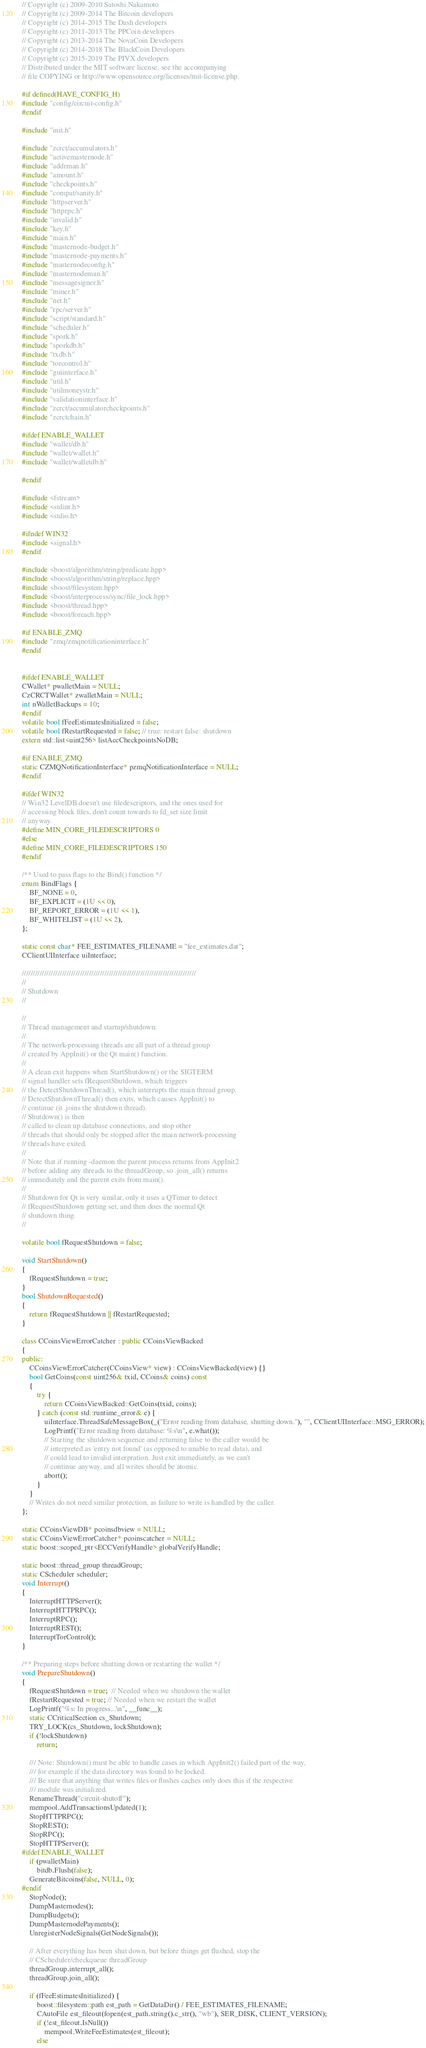Convert code to text. <code><loc_0><loc_0><loc_500><loc_500><_C++_>// Copyright (c) 2009-2010 Satoshi Nakamoto
// Copyright (c) 2009-2014 The Bitcoin developers
// Copyright (c) 2014-2015 The Dash developers
// Copyright (c) 2011-2013 The PPCoin developers
// Copyright (c) 2013-2014 The NovaCoin Developers
// Copyright (c) 2014-2018 The BlackCoin Developers
// Copyright (c) 2015-2019 The PIVX developers
// Distributed under the MIT software license, see the accompanying
// file COPYING or http://www.opensource.org/licenses/mit-license.php.

#if defined(HAVE_CONFIG_H)
#include "config/circuit-config.h"
#endif

#include "init.h"

#include "zcrct/accumulators.h"
#include "activemasternode.h"
#include "addrman.h"
#include "amount.h"
#include "checkpoints.h"
#include "compat/sanity.h"
#include "httpserver.h"
#include "httprpc.h"
#include "invalid.h"
#include "key.h"
#include "main.h"
#include "masternode-budget.h"
#include "masternode-payments.h"
#include "masternodeconfig.h"
#include "masternodeman.h"
#include "messagesigner.h"
#include "miner.h"
#include "net.h"
#include "rpc/server.h"
#include "script/standard.h"
#include "scheduler.h"
#include "spork.h"
#include "sporkdb.h"
#include "txdb.h"
#include "torcontrol.h"
#include "guiinterface.h"
#include "util.h"
#include "utilmoneystr.h"
#include "validationinterface.h"
#include "zcrct/accumulatorcheckpoints.h"
#include "zcrctchain.h"

#ifdef ENABLE_WALLET
#include "wallet/db.h"
#include "wallet/wallet.h"
#include "wallet/walletdb.h"

#endif

#include <fstream>
#include <stdint.h>
#include <stdio.h>

#ifndef WIN32
#include <signal.h>
#endif

#include <boost/algorithm/string/predicate.hpp>
#include <boost/algorithm/string/replace.hpp>
#include <boost/filesystem.hpp>
#include <boost/interprocess/sync/file_lock.hpp>
#include <boost/thread.hpp>
#include <boost/foreach.hpp>

#if ENABLE_ZMQ
#include "zmq/zmqnotificationinterface.h"
#endif


#ifdef ENABLE_WALLET
CWallet* pwalletMain = NULL;
CzCRCTWallet* zwalletMain = NULL;
int nWalletBackups = 10;
#endif
volatile bool fFeeEstimatesInitialized = false;
volatile bool fRestartRequested = false; // true: restart false: shutdown
extern std::list<uint256> listAccCheckpointsNoDB;

#if ENABLE_ZMQ
static CZMQNotificationInterface* pzmqNotificationInterface = NULL;
#endif

#ifdef WIN32
// Win32 LevelDB doesn't use filedescriptors, and the ones used for
// accessing block files, don't count towards to fd_set size limit
// anyway.
#define MIN_CORE_FILEDESCRIPTORS 0
#else
#define MIN_CORE_FILEDESCRIPTORS 150
#endif

/** Used to pass flags to the Bind() function */
enum BindFlags {
    BF_NONE = 0,
    BF_EXPLICIT = (1U << 0),
    BF_REPORT_ERROR = (1U << 1),
    BF_WHITELIST = (1U << 2),
};

static const char* FEE_ESTIMATES_FILENAME = "fee_estimates.dat";
CClientUIInterface uiInterface;

//////////////////////////////////////////////////////////////////////////////
//
// Shutdown
//

//
// Thread management and startup/shutdown:
//
// The network-processing threads are all part of a thread group
// created by AppInit() or the Qt main() function.
//
// A clean exit happens when StartShutdown() or the SIGTERM
// signal handler sets fRequestShutdown, which triggers
// the DetectShutdownThread(), which interrupts the main thread group.
// DetectShutdownThread() then exits, which causes AppInit() to
// continue (it .joins the shutdown thread).
// Shutdown() is then
// called to clean up database connections, and stop other
// threads that should only be stopped after the main network-processing
// threads have exited.
//
// Note that if running -daemon the parent process returns from AppInit2
// before adding any threads to the threadGroup, so .join_all() returns
// immediately and the parent exits from main().
//
// Shutdown for Qt is very similar, only it uses a QTimer to detect
// fRequestShutdown getting set, and then does the normal Qt
// shutdown thing.
//

volatile bool fRequestShutdown = false;

void StartShutdown()
{
    fRequestShutdown = true;
}
bool ShutdownRequested()
{
    return fRequestShutdown || fRestartRequested;
}

class CCoinsViewErrorCatcher : public CCoinsViewBacked
{
public:
    CCoinsViewErrorCatcher(CCoinsView* view) : CCoinsViewBacked(view) {}
    bool GetCoins(const uint256& txid, CCoins& coins) const
    {
        try {
            return CCoinsViewBacked::GetCoins(txid, coins);
        } catch (const std::runtime_error& e) {
            uiInterface.ThreadSafeMessageBox(_("Error reading from database, shutting down."), "", CClientUIInterface::MSG_ERROR);
            LogPrintf("Error reading from database: %s\n", e.what());
            // Starting the shutdown sequence and returning false to the caller would be
            // interpreted as 'entry not found' (as opposed to unable to read data), and
            // could lead to invalid interpration. Just exit immediately, as we can't
            // continue anyway, and all writes should be atomic.
            abort();
        }
    }
    // Writes do not need similar protection, as failure to write is handled by the caller.
};

static CCoinsViewDB* pcoinsdbview = NULL;
static CCoinsViewErrorCatcher* pcoinscatcher = NULL;
static boost::scoped_ptr<ECCVerifyHandle> globalVerifyHandle;

static boost::thread_group threadGroup;
static CScheduler scheduler;
void Interrupt()
{
    InterruptHTTPServer();
    InterruptHTTPRPC();
    InterruptRPC();
    InterruptREST();
    InterruptTorControl();
}

/** Preparing steps before shutting down or restarting the wallet */
void PrepareShutdown()
{
    fRequestShutdown = true;  // Needed when we shutdown the wallet
    fRestartRequested = true; // Needed when we restart the wallet
    LogPrintf("%s: In progress...\n", __func__);
    static CCriticalSection cs_Shutdown;
    TRY_LOCK(cs_Shutdown, lockShutdown);
    if (!lockShutdown)
        return;

    /// Note: Shutdown() must be able to handle cases in which AppInit2() failed part of the way,
    /// for example if the data directory was found to be locked.
    /// Be sure that anything that writes files or flushes caches only does this if the respective
    /// module was initialized.
    RenameThread("circuit-shutoff");
    mempool.AddTransactionsUpdated(1);
    StopHTTPRPC();
    StopREST();
    StopRPC();
    StopHTTPServer();
#ifdef ENABLE_WALLET
    if (pwalletMain)
        bitdb.Flush(false);
    GenerateBitcoins(false, NULL, 0);
#endif
    StopNode();
    DumpMasternodes();
    DumpBudgets();
    DumpMasternodePayments();
    UnregisterNodeSignals(GetNodeSignals());

    // After everything has been shut down, but before things get flushed, stop the
    // CScheduler/checkqueue threadGroup
    threadGroup.interrupt_all();
    threadGroup.join_all();

    if (fFeeEstimatesInitialized) {
        boost::filesystem::path est_path = GetDataDir() / FEE_ESTIMATES_FILENAME;
        CAutoFile est_fileout(fopen(est_path.string().c_str(), "wb"), SER_DISK, CLIENT_VERSION);
        if (!est_fileout.IsNull())
            mempool.WriteFeeEstimates(est_fileout);
        else</code> 